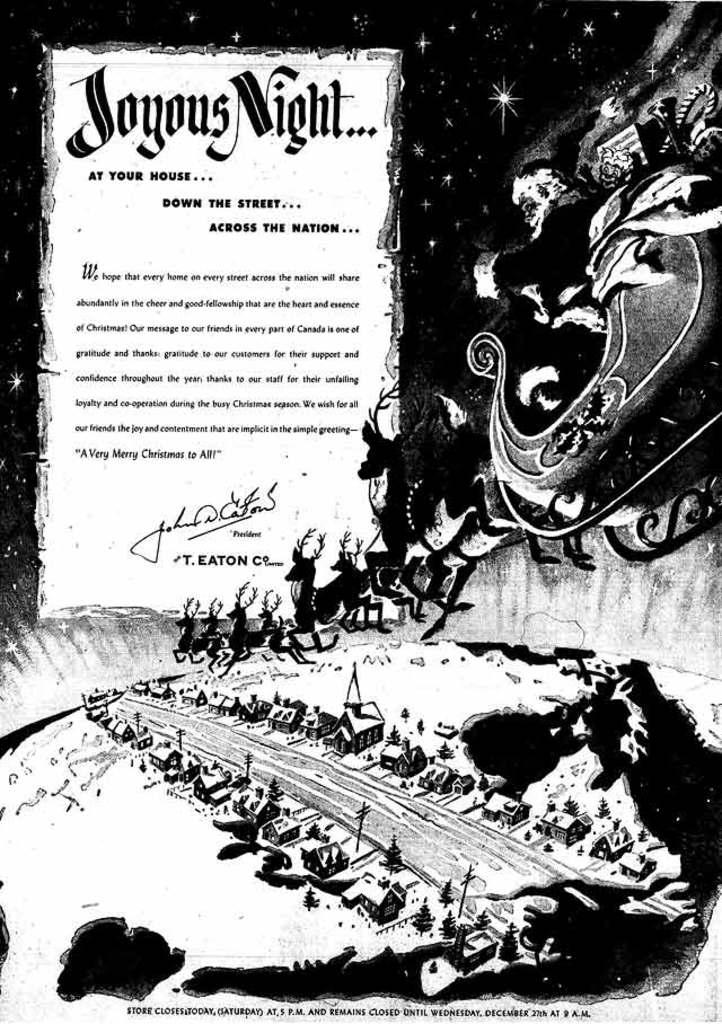<image>
Create a compact narrative representing the image presented. A black and white Christmas celebration ad with Santa flying over a town. 